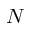Convert formula to latex. <formula><loc_0><loc_0><loc_500><loc_500>N</formula> 